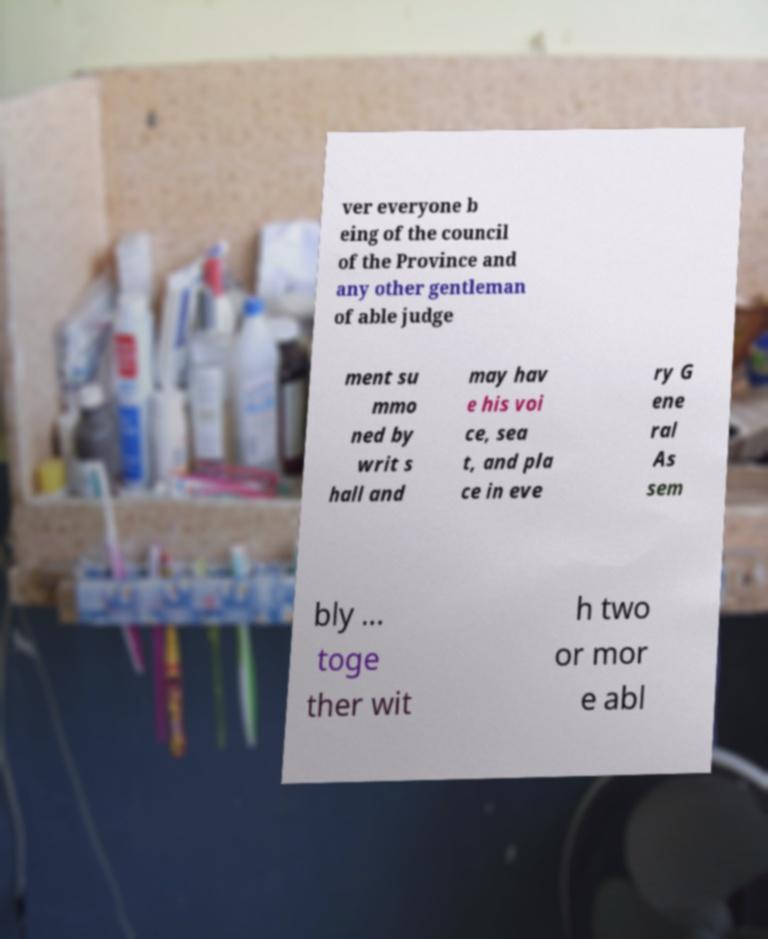There's text embedded in this image that I need extracted. Can you transcribe it verbatim? ver everyone b eing of the council of the Province and any other gentleman of able judge ment su mmo ned by writ s hall and may hav e his voi ce, sea t, and pla ce in eve ry G ene ral As sem bly ... toge ther wit h two or mor e abl 